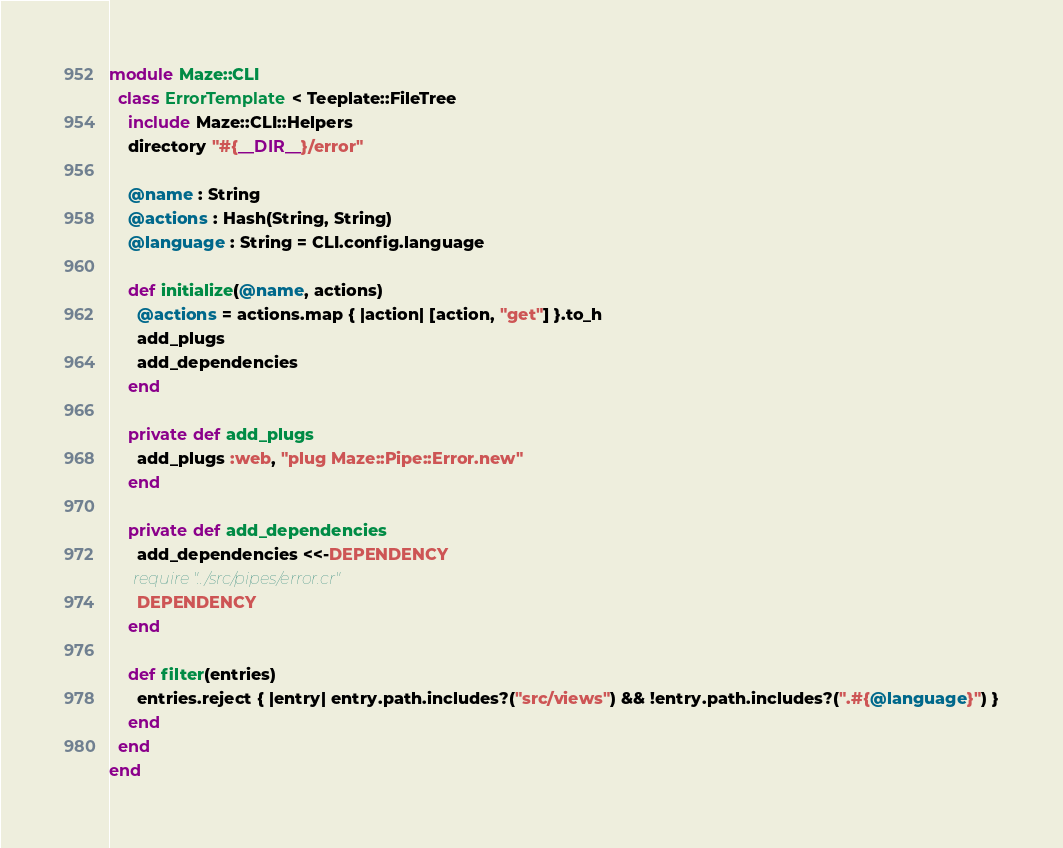Convert code to text. <code><loc_0><loc_0><loc_500><loc_500><_Crystal_>module Maze::CLI
  class ErrorTemplate < Teeplate::FileTree
    include Maze::CLI::Helpers
    directory "#{__DIR__}/error"

    @name : String
    @actions : Hash(String, String)
    @language : String = CLI.config.language

    def initialize(@name, actions)
      @actions = actions.map { |action| [action, "get"] }.to_h
      add_plugs
      add_dependencies
    end

    private def add_plugs
      add_plugs :web, "plug Maze::Pipe::Error.new"
    end

    private def add_dependencies
      add_dependencies <<-DEPENDENCY
      require "../src/pipes/error.cr"
      DEPENDENCY
    end

    def filter(entries)
      entries.reject { |entry| entry.path.includes?("src/views") && !entry.path.includes?(".#{@language}") }
    end
  end
end
</code> 